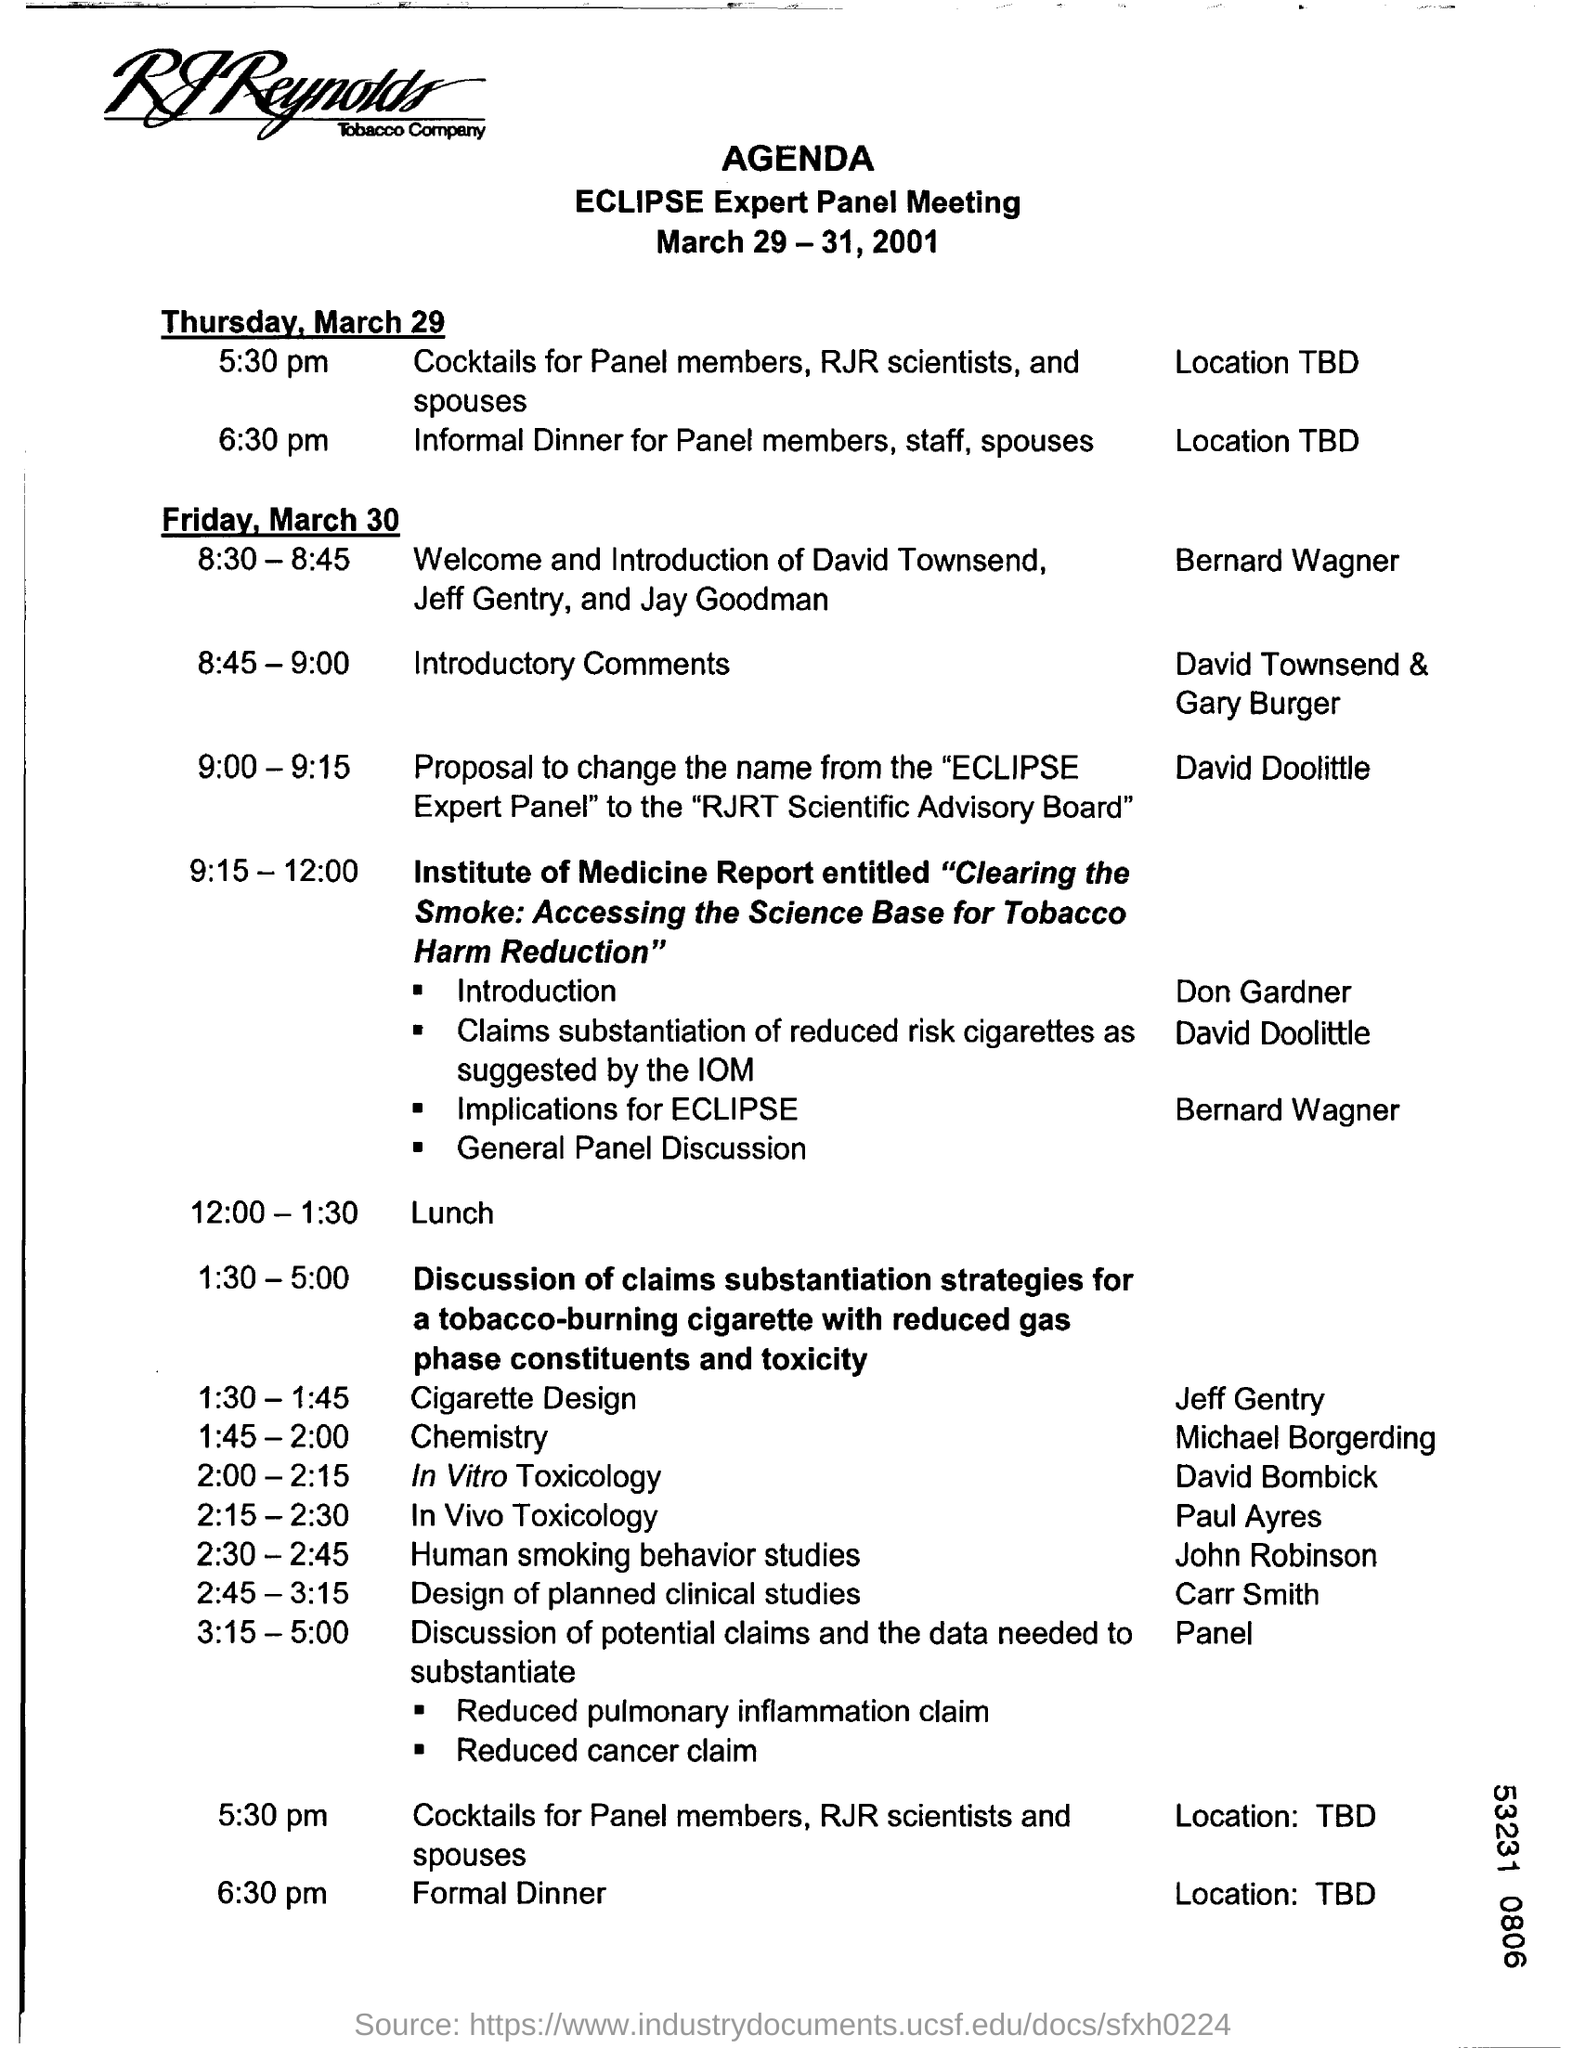Highlight a few significant elements in this photo. David Doolittle is proposing to change the name of the "eclipse expert panel" to the "RJRT scientific advisory board. The cocktail hour for panel members, RJR scientists, and their spouses will commence at 5:30 pm. The ECLIPSE Expert panel meeting is scheduled to be held from 9:00-9:15. The time allotted for discussing human smoking behavior studies is from 2:30 to 2:45. David Doolittle proposed between the time of 9:00 and 9:15. 